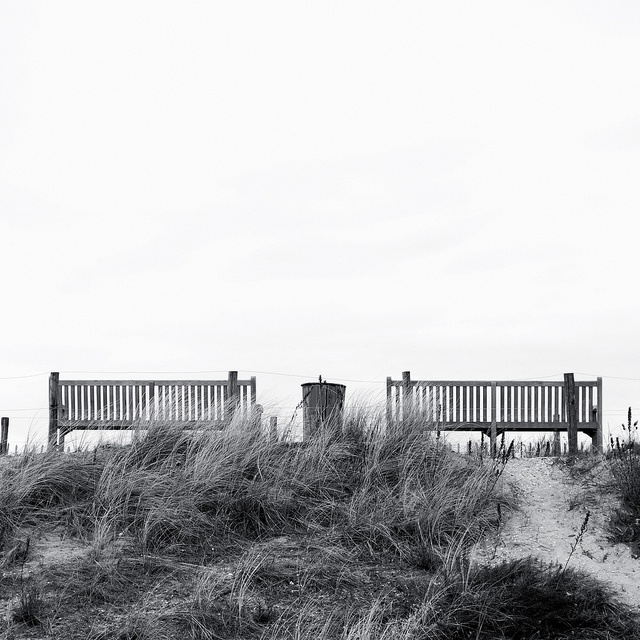Describe the objects in this image and their specific colors. I can see bench in white, gray, darkgray, and black tones and bench in white, darkgray, gray, and black tones in this image. 